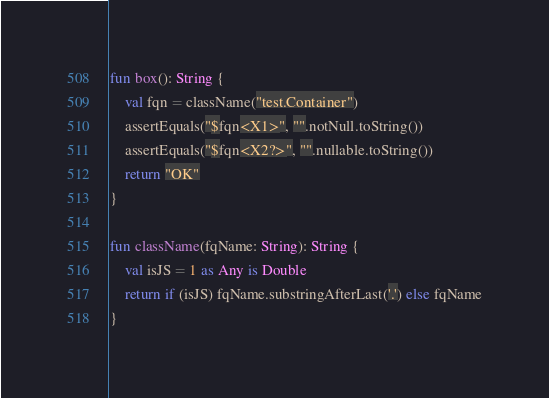<code> <loc_0><loc_0><loc_500><loc_500><_Kotlin_>
fun box(): String {
    val fqn = className("test.Container")
    assertEquals("$fqn<X1>", "".notNull.toString())
    assertEquals("$fqn<X2?>", "".nullable.toString())
    return "OK"
}

fun className(fqName: String): String {
    val isJS = 1 as Any is Double
    return if (isJS) fqName.substringAfterLast('.') else fqName
}
</code> 